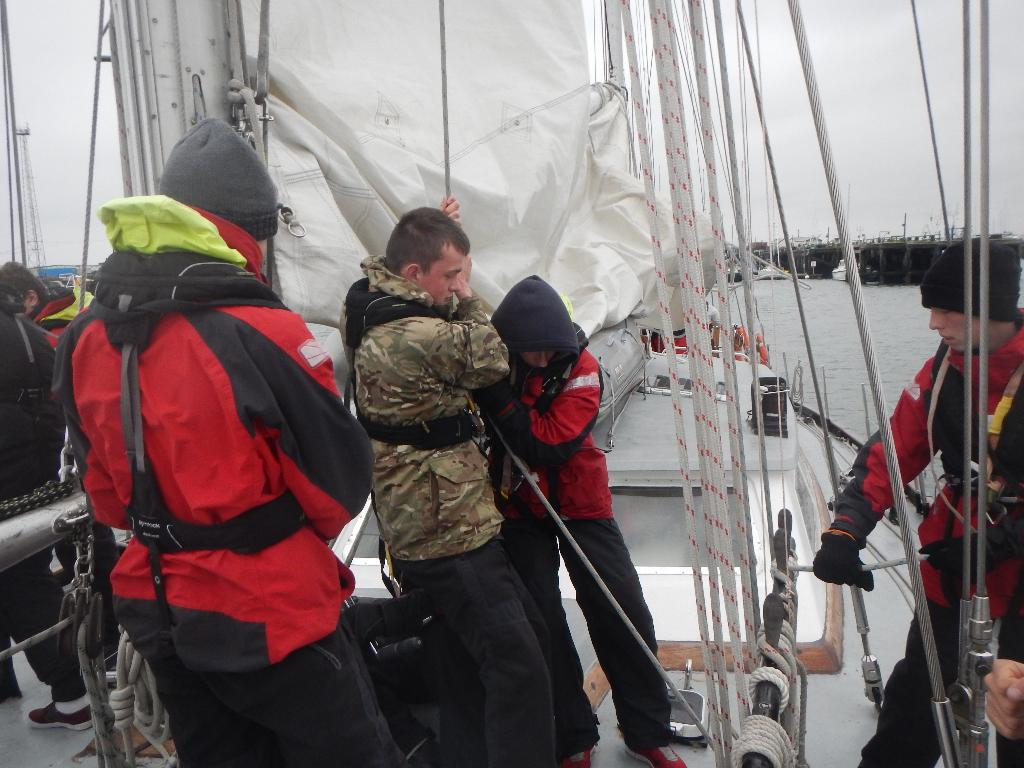What are the persons in the image doing? The persons in the image are standing on a boat and holding ropes. What is the color of the sheet visible in the image? The sheet is white in color. What can be seen in the background of the image? There is water, other boats, and the sky visible in the background. How many apples are being held by the persons on the boat? There is no mention of apples in the image, so it cannot be determined how many apples are being held. What type of authority is represented by the persons on the boat? There is no indication of authority in the image; the persons are simply holding ropes on a boat. 